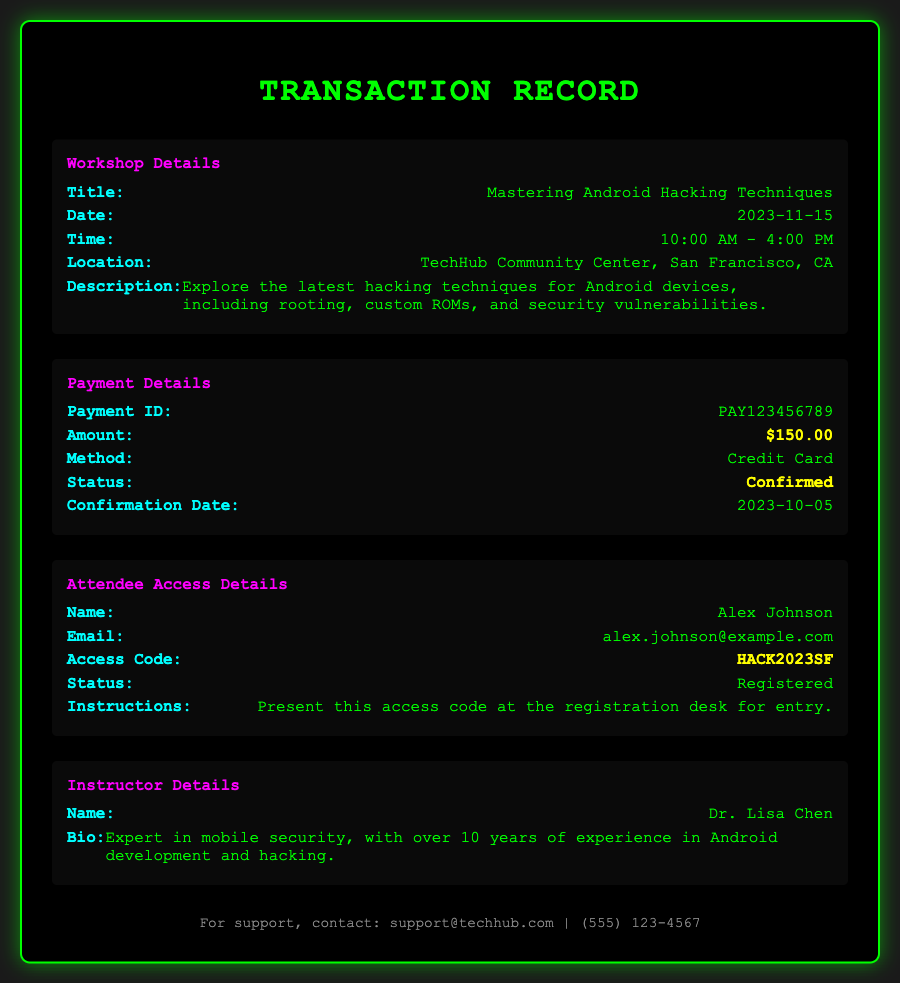What is the title of the workshop? The title of the workshop is provided in the document under Workshop Details.
Answer: Mastering Android Hacking Techniques What is the payment amount? The payment amount is listed in the Payment Details section of the document.
Answer: $150.00 What date is the workshop scheduled for? The date of the workshop is found in the Workshop Details section.
Answer: 2023-11-15 Who is the instructor of the workshop? The instructor's details are provided in the Instructor Details section.
Answer: Dr. Lisa Chen What method was used for payment? The payment method is specified in the Payment Details section of the document.
Answer: Credit Card What is the access code for the attendee? The access code is found in the Attendee Access Details section.
Answer: HACK2023SF What is the status of the payment? The payment status can be found in the Payment Details section.
Answer: Confirmed What instructions are given for entry? The instructions for entry are detailed in the Attendee Access Details section.
Answer: Present this access code at the registration desk for entry How long does the workshop run? The duration of the workshop is specified in the time section under Workshop Details.
Answer: 10:00 AM - 4:00 PM 